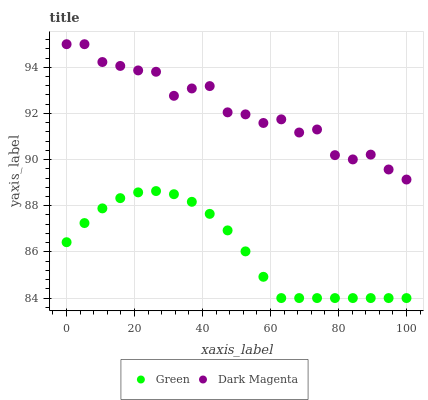Does Green have the minimum area under the curve?
Answer yes or no. Yes. Does Dark Magenta have the maximum area under the curve?
Answer yes or no. Yes. Does Dark Magenta have the minimum area under the curve?
Answer yes or no. No. Is Green the smoothest?
Answer yes or no. Yes. Is Dark Magenta the roughest?
Answer yes or no. Yes. Is Dark Magenta the smoothest?
Answer yes or no. No. Does Green have the lowest value?
Answer yes or no. Yes. Does Dark Magenta have the lowest value?
Answer yes or no. No. Does Dark Magenta have the highest value?
Answer yes or no. Yes. Is Green less than Dark Magenta?
Answer yes or no. Yes. Is Dark Magenta greater than Green?
Answer yes or no. Yes. Does Green intersect Dark Magenta?
Answer yes or no. No. 